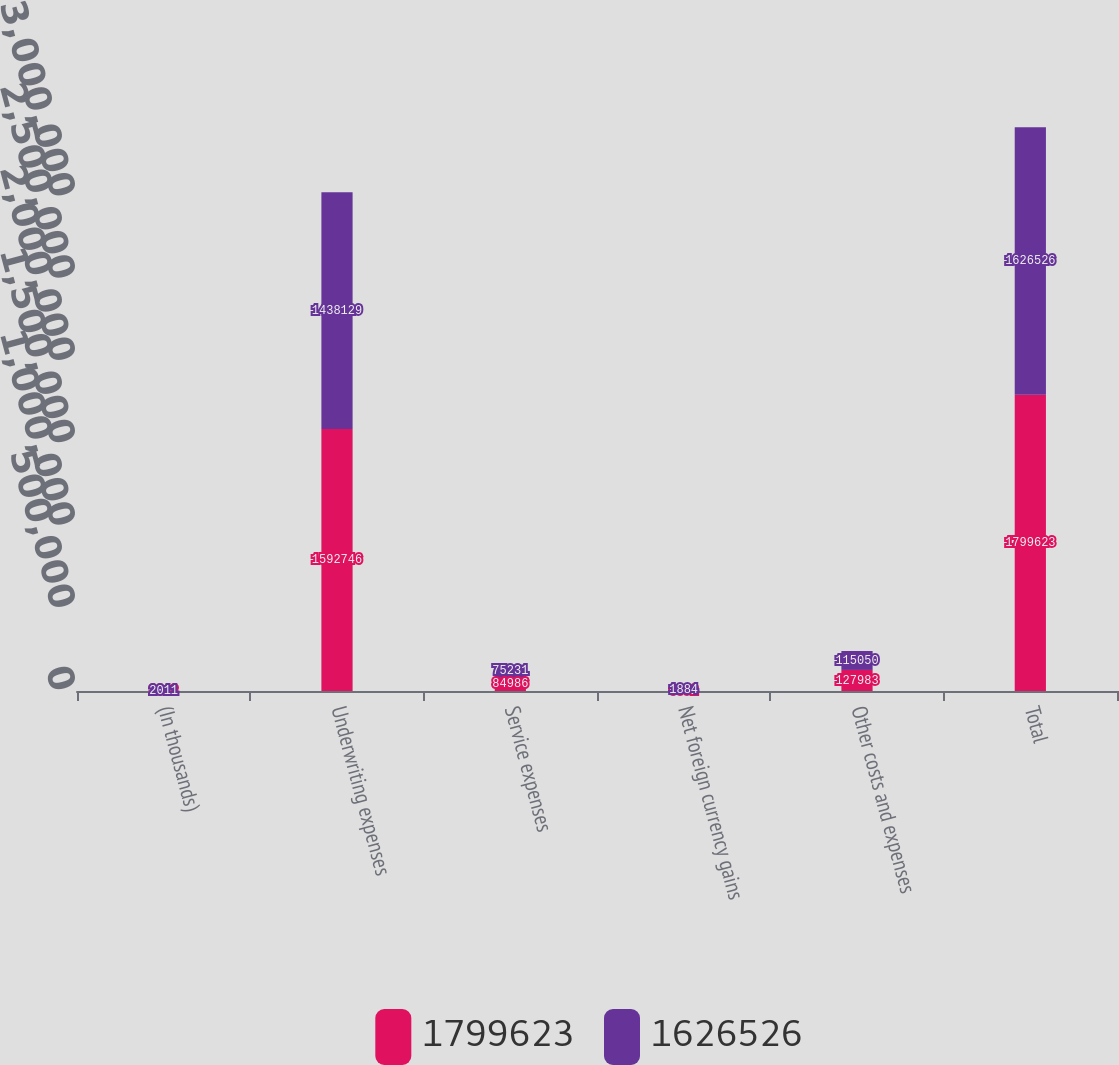Convert chart to OTSL. <chart><loc_0><loc_0><loc_500><loc_500><stacked_bar_chart><ecel><fcel>(In thousands)<fcel>Underwriting expenses<fcel>Service expenses<fcel>Net foreign currency gains<fcel>Other costs and expenses<fcel>Total<nl><fcel>1.79962e+06<fcel>2012<fcel>1.59275e+06<fcel>84986<fcel>6092<fcel>127983<fcel>1.79962e+06<nl><fcel>1.62653e+06<fcel>2011<fcel>1.43813e+06<fcel>75231<fcel>1884<fcel>115050<fcel>1.62653e+06<nl></chart> 